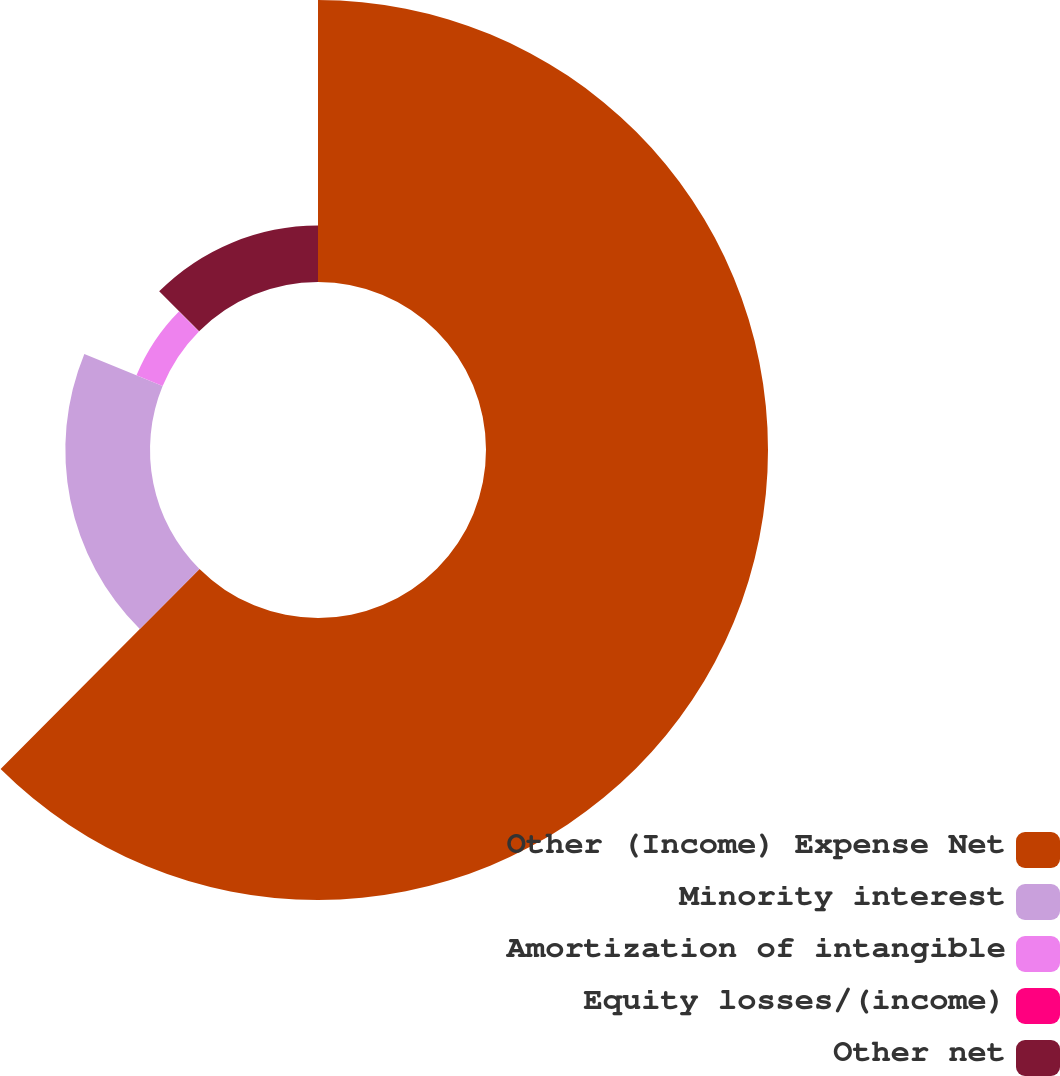Convert chart to OTSL. <chart><loc_0><loc_0><loc_500><loc_500><pie_chart><fcel>Other (Income) Expense Net<fcel>Minority interest<fcel>Amortization of intangible<fcel>Equity losses/(income)<fcel>Other net<nl><fcel>62.46%<fcel>18.75%<fcel>6.26%<fcel>0.02%<fcel>12.51%<nl></chart> 